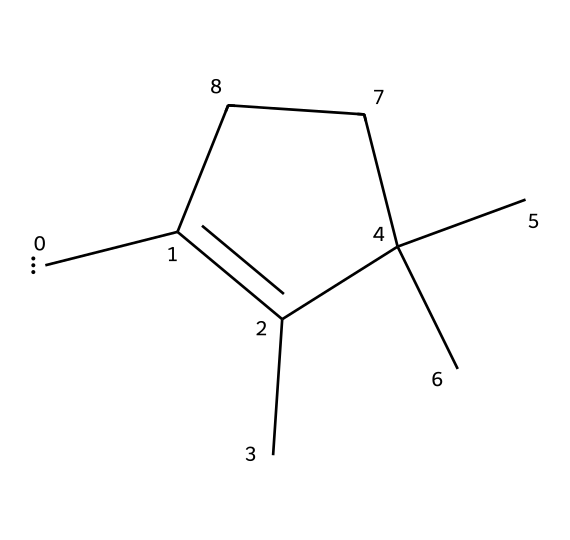What is the number of carbon atoms in this compound? Looking at the SMILES representation, each 'C' denotes a carbon atom, and by counting them, there are a total of 9 carbon atoms present in the structure.
Answer: 9 How many double bonds are in this chemical structure? The SMILES shows the structure has a double bond, which is indicated by the '=' symbol between two carbon atoms. By identifying the connections, we see there is 1 double bond.
Answer: 1 Is this compound a cyclic structure? The presence of the number '1' in the SMILES signifies the start and end of a ring, indicating it is a cyclic compound. Hence, the answer is yes, it is cyclic.
Answer: yes What functional group is primarily represented in this compound? In this chemical, the central carbon atom is bonded to another carbon atom (signifying it is a carbene), which indicates that it is a carbene characteristic. This functional group is prominent in the structure.
Answer: carbene How many hydrogen atoms are attached to the carbene carbon? The carbene carbon is attached to one other carbon and has 2 additional hydrogen atoms because it is bonded to two other groups, thus completing its tetravalence. Hence, the total number is 2.
Answer: 2 What is the total number of bonds present in the structure? By analyzing the structure, we can count all the carbon-carbon and carbon-hydrogen bonds. There are 12 single bonds and 1 double bond, totaling 13 bonds.
Answer: 13 